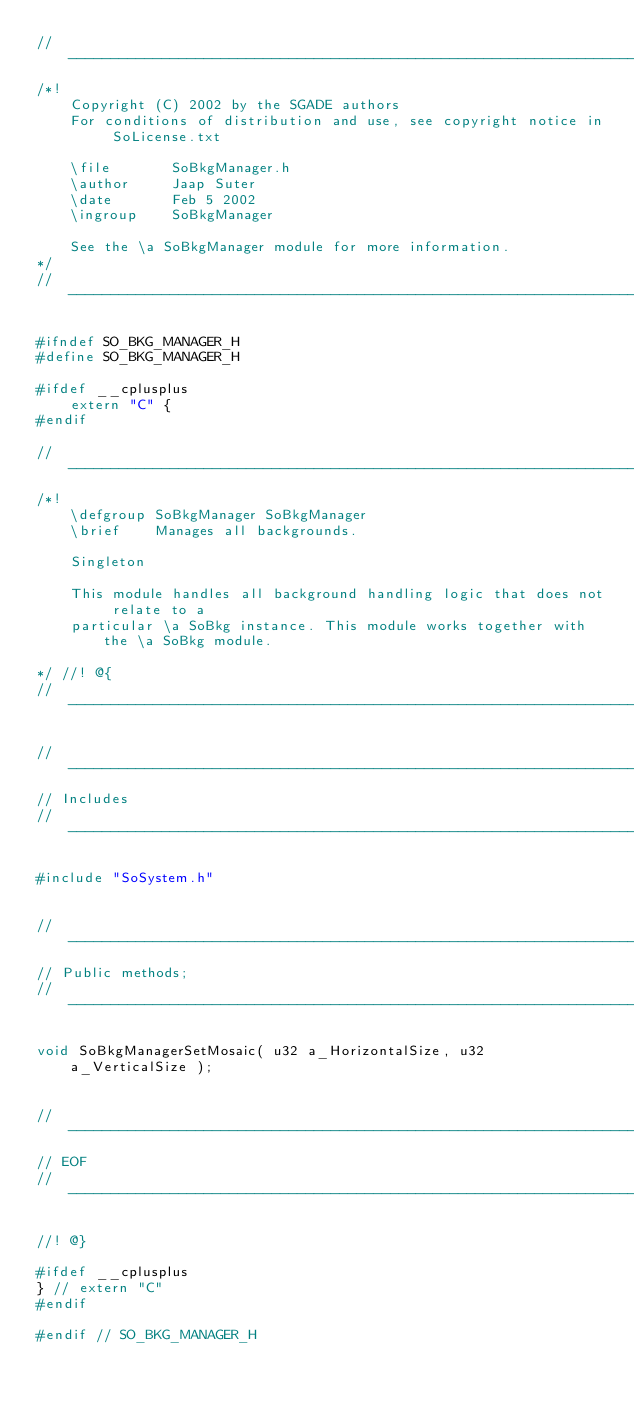Convert code to text. <code><loc_0><loc_0><loc_500><loc_500><_C_>// ----------------------------------------------------------------------------
/*! 
	Copyright (C) 2002 by the SGADE authors
	For conditions of distribution and use, see copyright notice in SoLicense.txt

	\file		SoBkgManager.h
	\author		Jaap Suter
	\date		Feb 5 2002
	\ingroup	SoBkgManager

	See the \a SoBkgManager module for more information.
*/
// ----------------------------------------------------------------------------

#ifndef SO_BKG_MANAGER_H
#define SO_BKG_MANAGER_H

#ifdef __cplusplus
	extern "C" {
#endif

// ----------------------------------------------------------------------------
/*! 
	\defgroup SoBkgManager SoBkgManager
	\brief	  Manages all backgrounds.

	Singleton

	This module handles all background handling logic that does not relate to a
	particular \a SoBkg instance. This module works together with the \a SoBkg module.

*/ //! @{
// ----------------------------------------------------------------------------

// ----------------------------------------------------------------------------
// Includes
// ----------------------------------------------------------------------------

#include "SoSystem.h"


// ----------------------------------------------------------------------------
// Public methods;
// ----------------------------------------------------------------------------

void SoBkgManagerSetMosaic( u32 a_HorizontalSize, u32 a_VerticalSize );


// ----------------------------------------------------------------------------
// EOF
// ----------------------------------------------------------------------------

//! @}

#ifdef __cplusplus
} // extern "C"
#endif

#endif // SO_BKG_MANAGER_H
</code> 